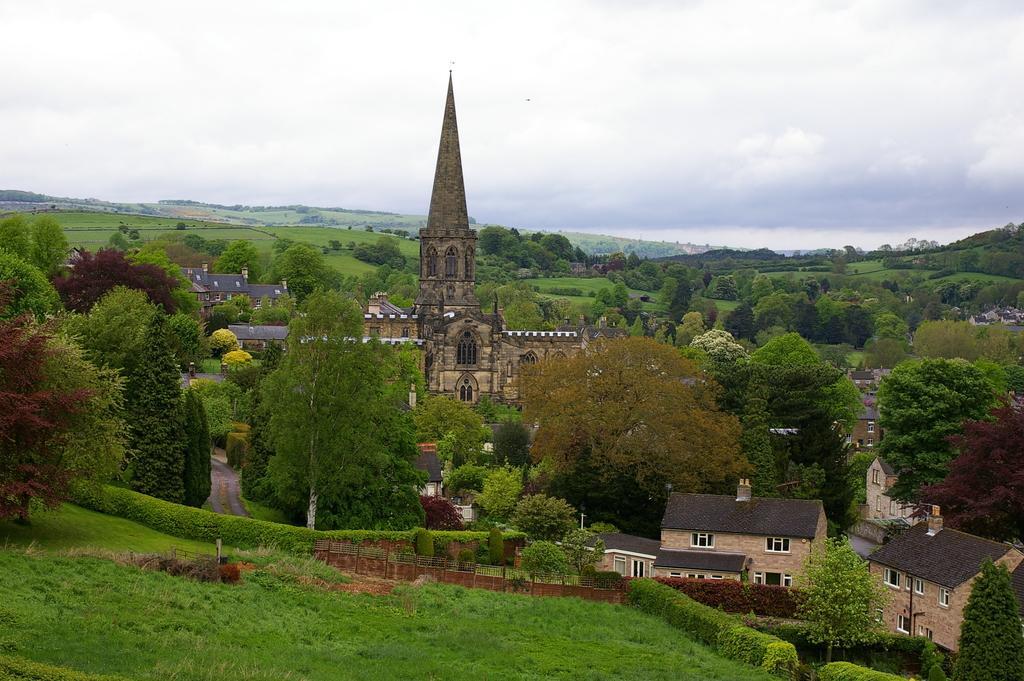Please provide a concise description of this image. In this image we can see a few buildings, there are some plants, trees, grass and windows, in the background we can see the sky with clouds. 